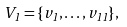<formula> <loc_0><loc_0><loc_500><loc_500>V _ { 1 } = \{ v _ { 1 } , \dots , v _ { 1 1 } \} ,</formula> 